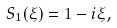Convert formula to latex. <formula><loc_0><loc_0><loc_500><loc_500>S _ { 1 } ( \xi ) = 1 - i \xi ,</formula> 